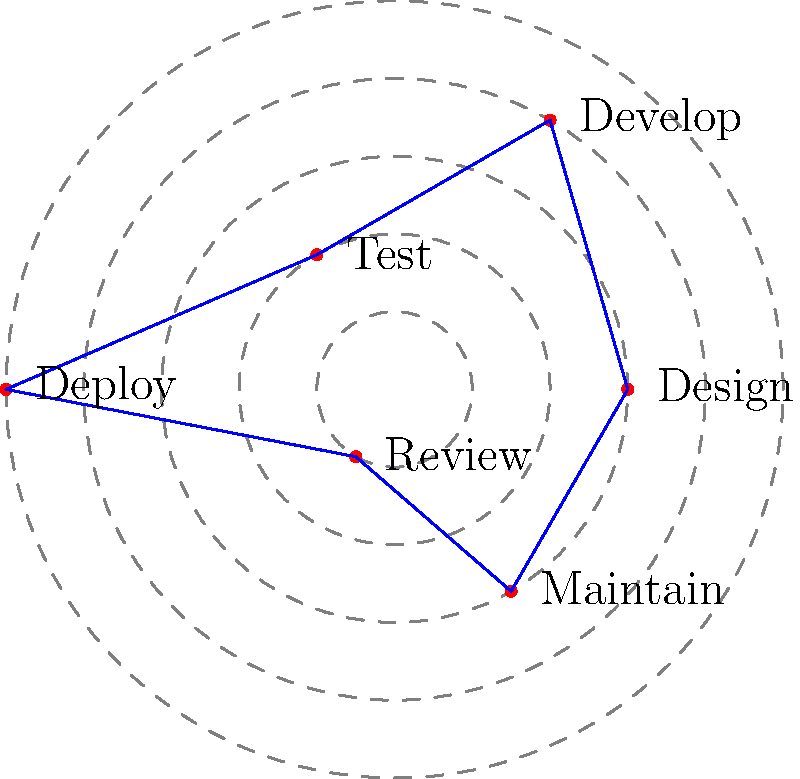As a project manager, you are using a polar graph to visualize the timeline and progress of a software project. The radial distance represents the time spent on each phase (in months), and the angular position represents the sequence of phases. Given the polar graph above, what is the total duration of the project in months, and which phase took the longest time? To solve this problem, we need to follow these steps:

1. Identify the phases and their corresponding radial distances (time spent in months):
   - Design: 3 months
   - Develop: 4 months
   - Test: 2 months
   - Deploy: 5 months
   - Review: 1 month
   - Maintain: 3 months

2. Calculate the total duration of the project:
   $$ \text{Total duration} = 3 + 4 + 2 + 5 + 1 + 3 = 18 \text{ months} $$

3. Identify the phase that took the longest time:
   The longest radial distance on the graph corresponds to the "Deploy" phase, which took 5 months.

Therefore, the total duration of the project is 18 months, and the phase that took the longest time is the Deploy phase.
Answer: 18 months; Deploy phase 